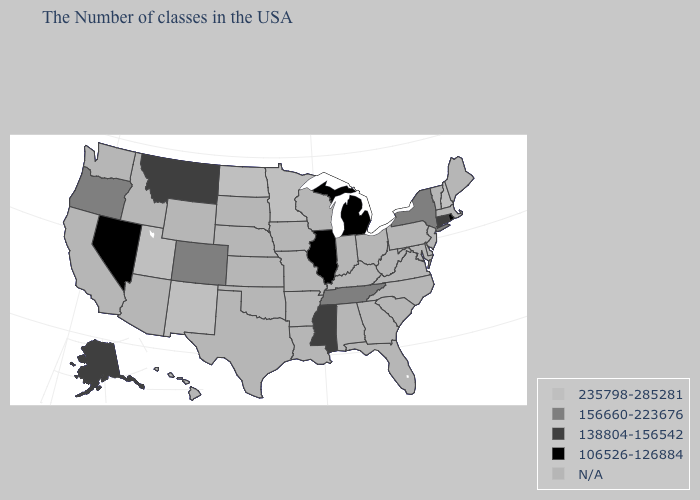What is the value of Wyoming?
Be succinct. N/A. Name the states that have a value in the range 138804-156542?
Concise answer only. Connecticut, Mississippi, Montana, Alaska. What is the value of Arkansas?
Quick response, please. N/A. What is the value of Louisiana?
Be succinct. N/A. Does Utah have the highest value in the USA?
Quick response, please. Yes. What is the lowest value in states that border Georgia?
Quick response, please. 156660-223676. What is the value of New Mexico?
Answer briefly. 235798-285281. What is the value of Vermont?
Answer briefly. N/A. Is the legend a continuous bar?
Concise answer only. No. Does Mississippi have the lowest value in the South?
Be succinct. Yes. Among the states that border Wyoming , which have the highest value?
Keep it brief. Utah. Which states hav the highest value in the Northeast?
Answer briefly. New Hampshire. What is the lowest value in the Northeast?
Answer briefly. 106526-126884. 